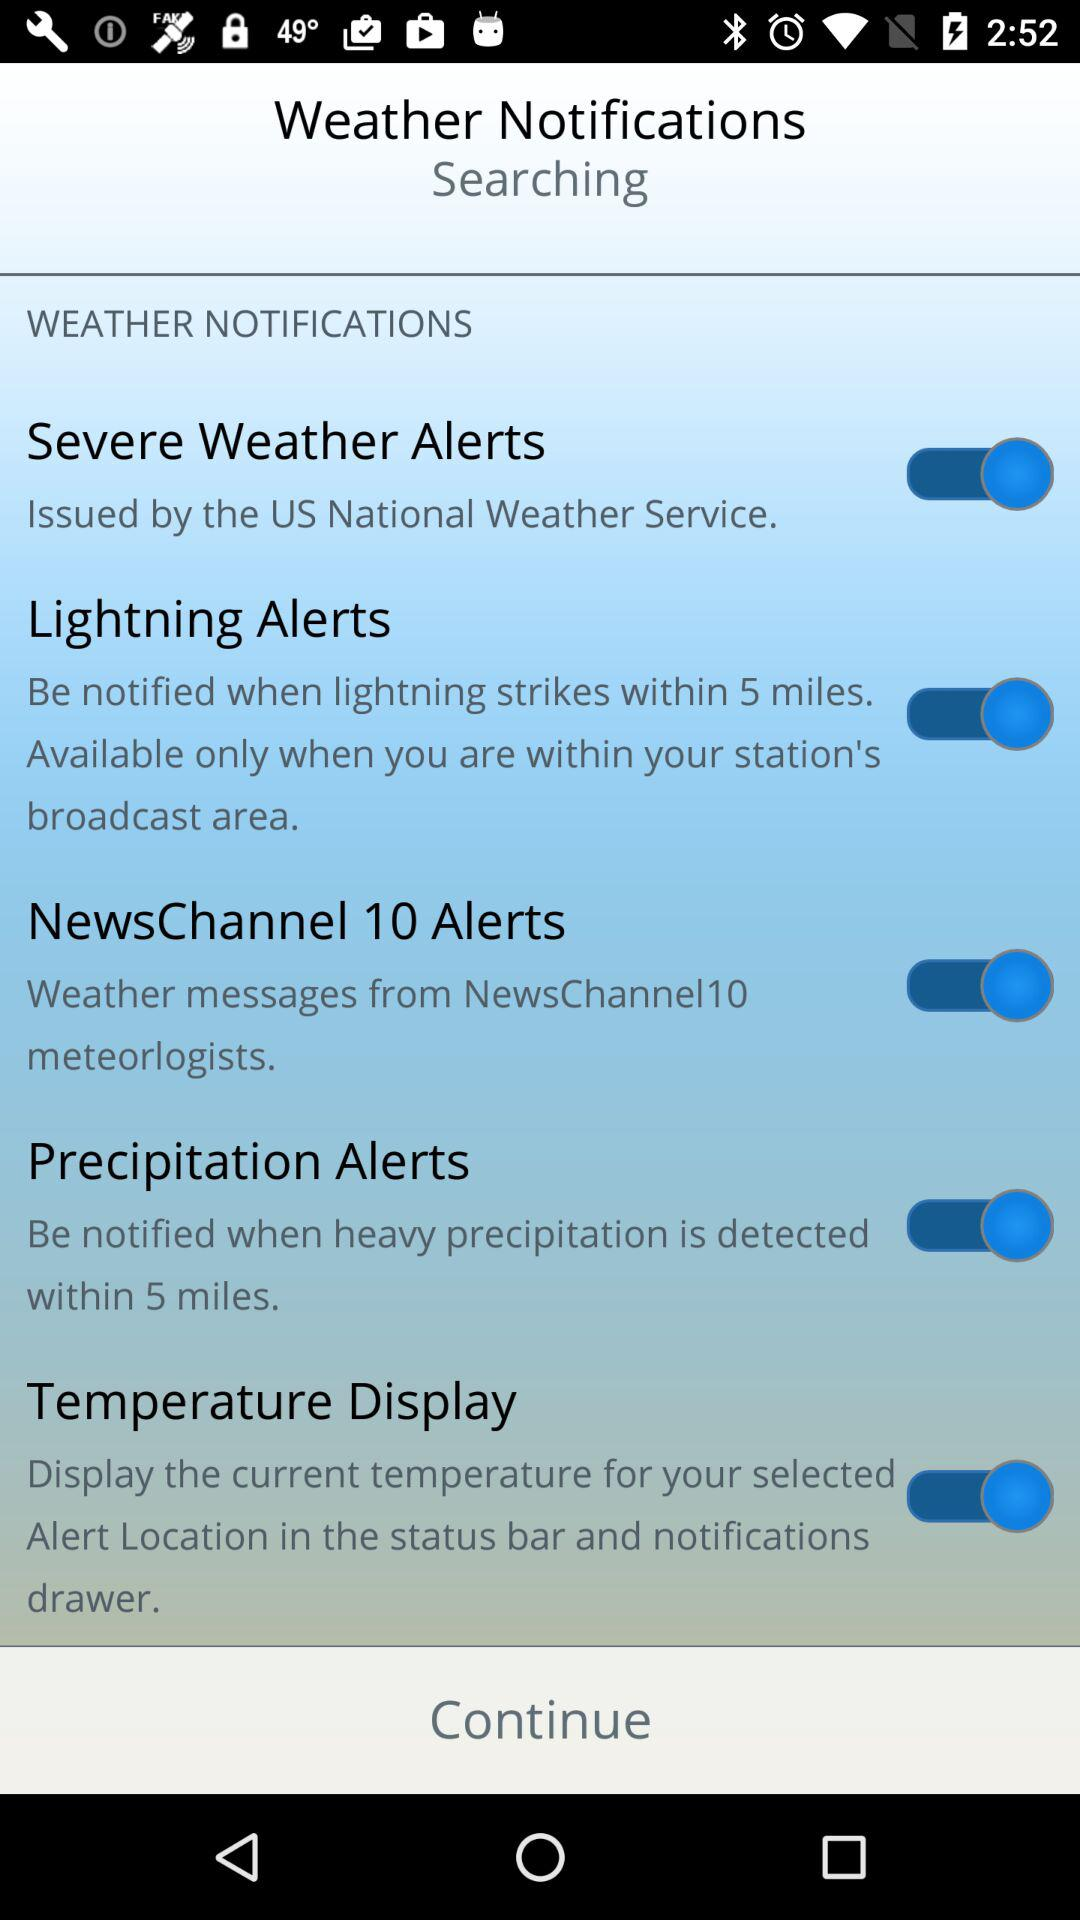What is the status of the "Temperature Display"? The status is "on". 